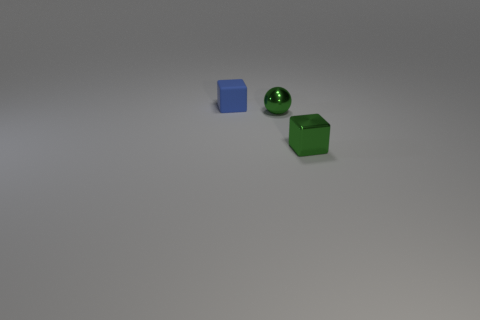Add 2 green shiny cubes. How many objects exist? 5 Subtract all blocks. How many objects are left? 1 Add 1 tiny green metal cubes. How many tiny green metal cubes are left? 2 Add 1 shiny cubes. How many shiny cubes exist? 2 Subtract 0 cyan balls. How many objects are left? 3 Subtract all tiny green balls. Subtract all small metallic spheres. How many objects are left? 1 